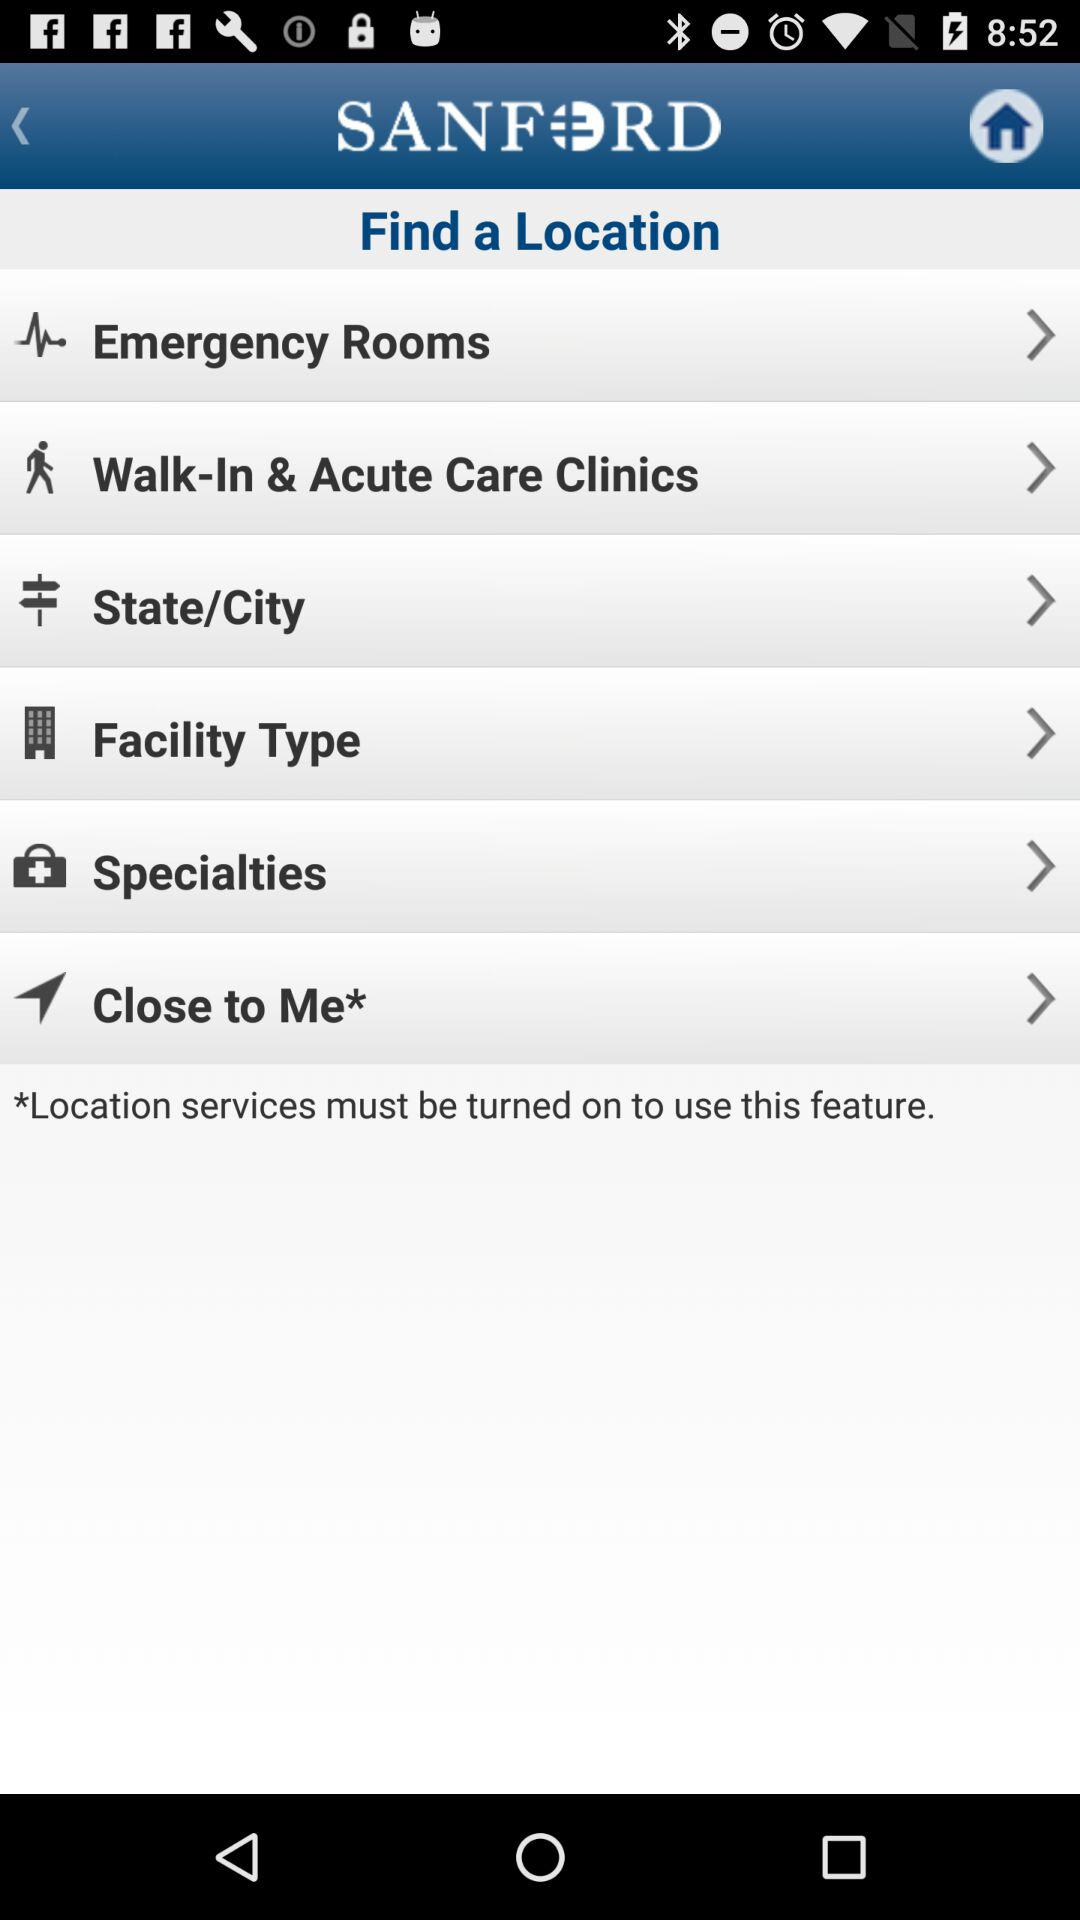What is the name of the application? The name of the application is "SANFORD". 